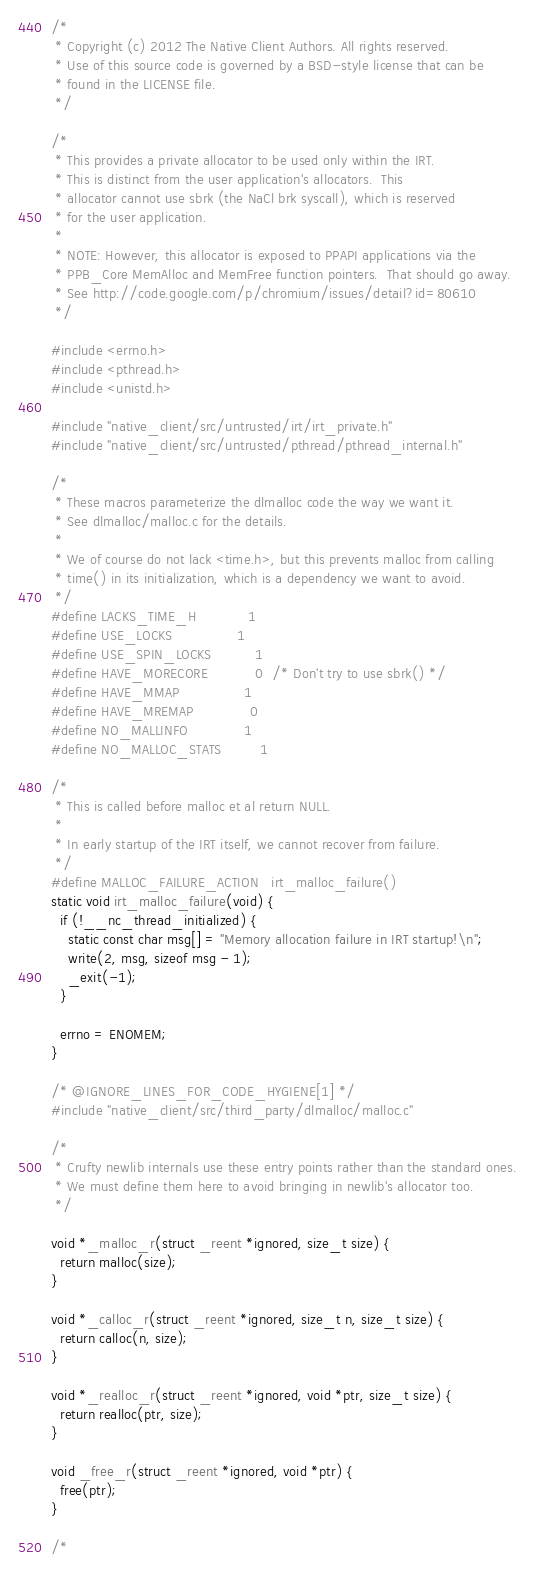Convert code to text. <code><loc_0><loc_0><loc_500><loc_500><_C_>/*
 * Copyright (c) 2012 The Native Client Authors. All rights reserved.
 * Use of this source code is governed by a BSD-style license that can be
 * found in the LICENSE file.
 */

/*
 * This provides a private allocator to be used only within the IRT.
 * This is distinct from the user application's allocators.  This
 * allocator cannot use sbrk (the NaCl brk syscall), which is reserved
 * for the user application.
 *
 * NOTE: However, this allocator is exposed to PPAPI applications via the
 * PPB_Core MemAlloc and MemFree function pointers.  That should go away.
 * See http://code.google.com/p/chromium/issues/detail?id=80610
 */

#include <errno.h>
#include <pthread.h>
#include <unistd.h>

#include "native_client/src/untrusted/irt/irt_private.h"
#include "native_client/src/untrusted/pthread/pthread_internal.h"

/*
 * These macros parameterize the dlmalloc code the way we want it.
 * See dlmalloc/malloc.c for the details.
 *
 * We of course do not lack <time.h>, but this prevents malloc from calling
 * time() in its initialization, which is a dependency we want to avoid.
 */
#define LACKS_TIME_H            1
#define USE_LOCKS               1
#define USE_SPIN_LOCKS          1
#define HAVE_MORECORE           0  /* Don't try to use sbrk() */
#define HAVE_MMAP               1
#define HAVE_MREMAP             0
#define NO_MALLINFO             1
#define NO_MALLOC_STATS         1

/*
 * This is called before malloc et al return NULL.
 *
 * In early startup of the IRT itself, we cannot recover from failure.
 */
#define MALLOC_FAILURE_ACTION   irt_malloc_failure()
static void irt_malloc_failure(void) {
  if (!__nc_thread_initialized) {
    static const char msg[] = "Memory allocation failure in IRT startup!\n";
    write(2, msg, sizeof msg - 1);
    _exit(-1);
  }

  errno = ENOMEM;
}

/* @IGNORE_LINES_FOR_CODE_HYGIENE[1] */
#include "native_client/src/third_party/dlmalloc/malloc.c"

/*
 * Crufty newlib internals use these entry points rather than the standard ones.
 * We must define them here to avoid bringing in newlib's allocator too.
 */

void *_malloc_r(struct _reent *ignored, size_t size) {
  return malloc(size);
}

void *_calloc_r(struct _reent *ignored, size_t n, size_t size) {
  return calloc(n, size);
}

void *_realloc_r(struct _reent *ignored, void *ptr, size_t size) {
  return realloc(ptr, size);
}

void _free_r(struct _reent *ignored, void *ptr) {
  free(ptr);
}

/*</code> 